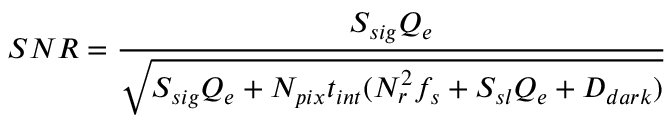<formula> <loc_0><loc_0><loc_500><loc_500>S N R = \frac { S _ { s i g } Q _ { e } } { \sqrt { S _ { s i g } Q _ { e } + N _ { p i x } t _ { i n t } ( N _ { r } ^ { 2 } f _ { s } + S _ { s l } Q _ { e } + D _ { d a r k } ) } }</formula> 